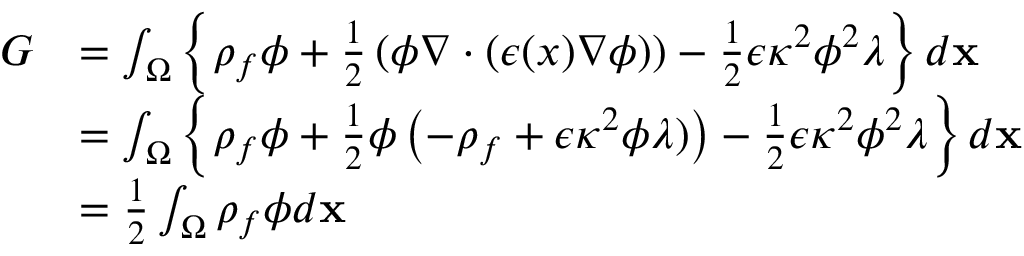<formula> <loc_0><loc_0><loc_500><loc_500>\begin{array} { r l } { G } & { = \int _ { \Omega } \left \{ \rho _ { f } \phi + \frac { 1 } { 2 } \left ( \phi \nabla \cdot ( \epsilon ( x ) \nabla \phi ) \right ) - \frac { 1 } { 2 } \epsilon \kappa ^ { 2 } \phi ^ { 2 } \lambda \right \} d x } \\ & { = \int _ { \Omega } \left \{ \rho _ { f } \phi + \frac { 1 } { 2 } \phi \left ( - \rho _ { f } + \epsilon \kappa ^ { 2 } \phi \lambda ) \right ) - \frac { 1 } { 2 } \epsilon \kappa ^ { 2 } \phi ^ { 2 } \lambda \right \} d x } \\ & { = \frac { 1 } { 2 } \int _ { \Omega } \rho _ { f } \phi d x } \end{array}</formula> 